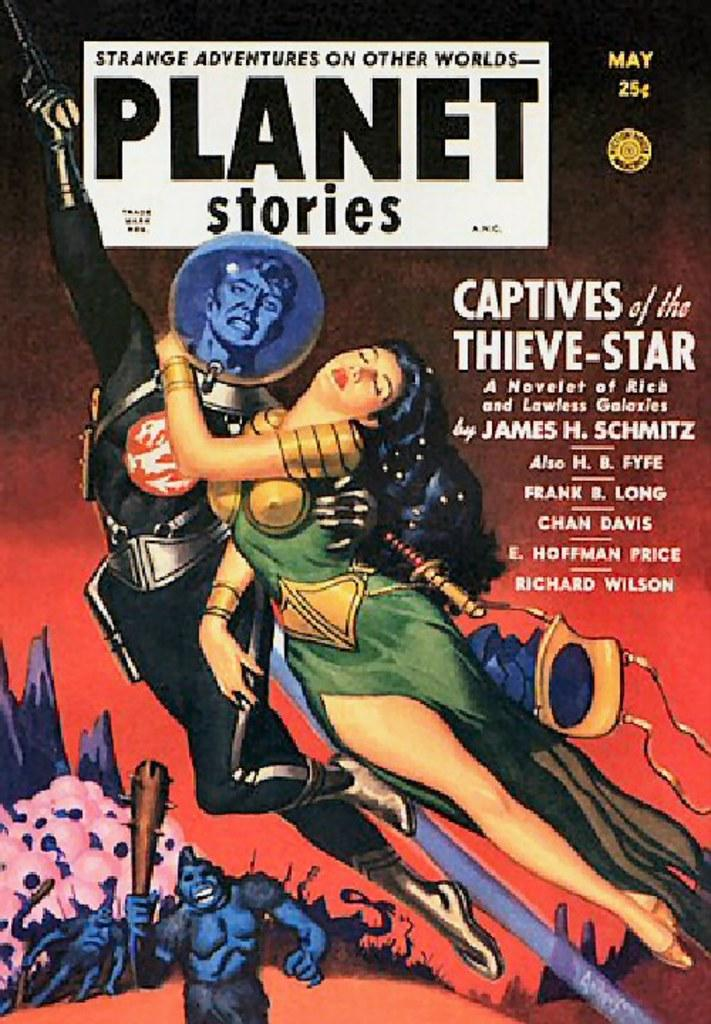<image>
Write a terse but informative summary of the picture. A comic book cover of Strange Adventures on Other Worlds, Planet Series is marked as 25 cents for this May edition. 